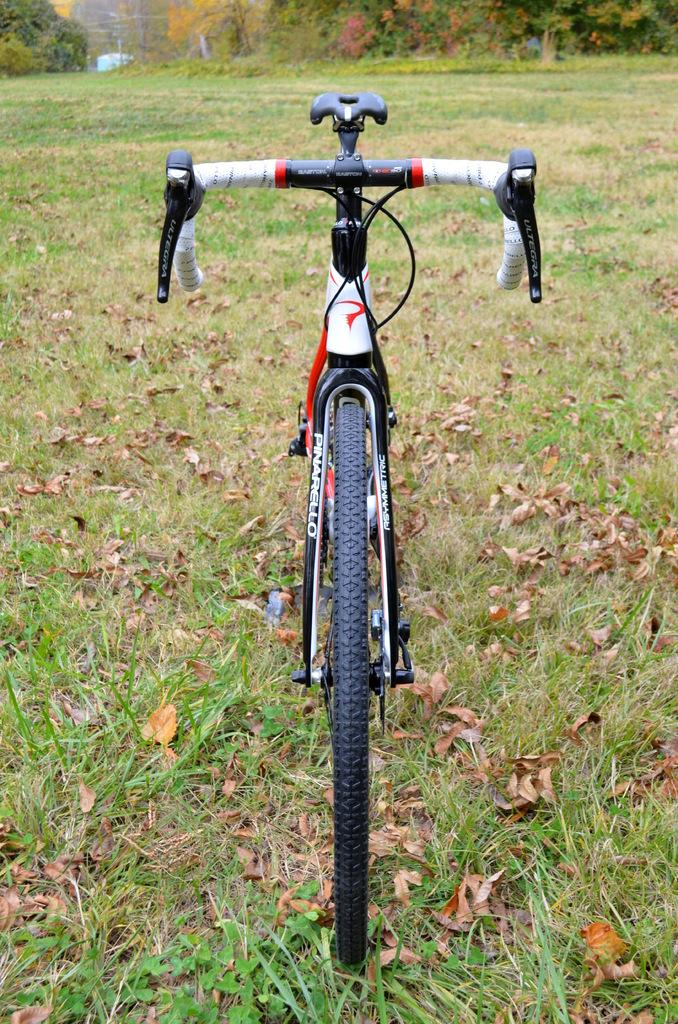What is the main object in the image? There is a cycle in the image. Where is the cycle located? The cycle is parked on a round surface. What type of vegetation is visible at the bottom of the image? There is green grass at the bottom of the image. What can be seen in the background of the image? There are trees in the background of the image. How many oranges are hanging from the trees in the image? There are no oranges visible in the image; only trees are present in the background. What type of cracker is being used to rub the cycle in the image? There is no cracker or rubbing action present in the image; the cycle is parked on a round surface. 